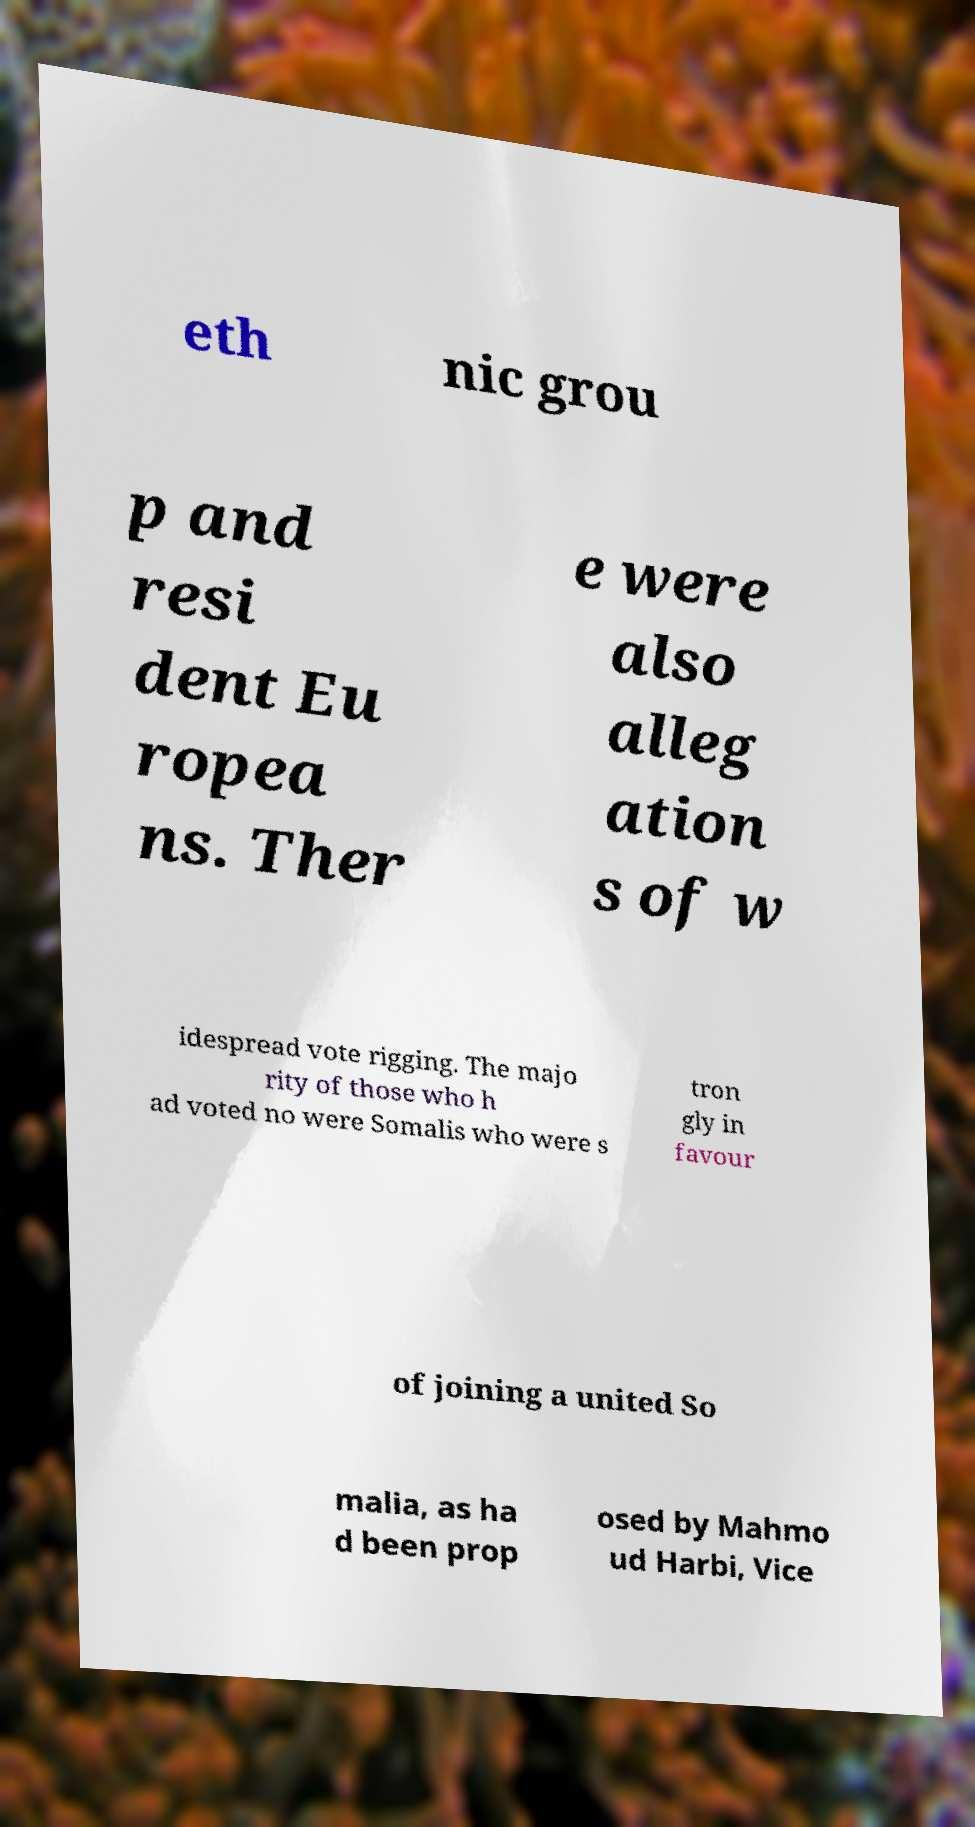Can you read and provide the text displayed in the image?This photo seems to have some interesting text. Can you extract and type it out for me? eth nic grou p and resi dent Eu ropea ns. Ther e were also alleg ation s of w idespread vote rigging. The majo rity of those who h ad voted no were Somalis who were s tron gly in favour of joining a united So malia, as ha d been prop osed by Mahmo ud Harbi, Vice 